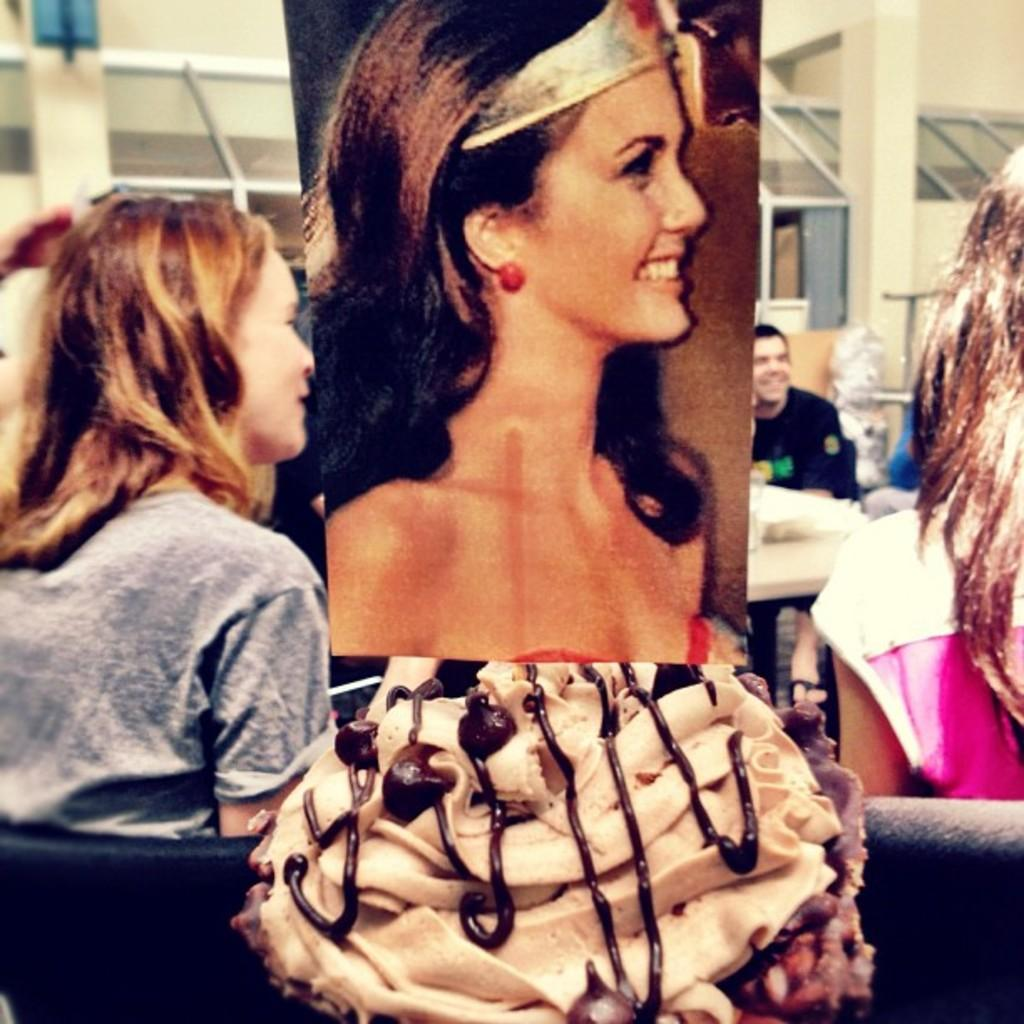What are the people in the image doing? There are persons sitting on chairs in the image. What can be seen on the advertisement board in the image? There is an advertisement board with a woman's picture in the image. What type of food is visible in the image? Dessert is visible in the image. What type of structure is present in the image? Iron grills are present in the image. What type of architectural feature is visible in the image? There are walls in the image. What type of slave is depicted in the image? There is no slave depicted in the image; it features persons sitting on chairs, an advertisement board, dessert, iron grills, and walls. What type of stamp can be seen on the governor's forehead in the image? There is no governor or stamp present in the image. 